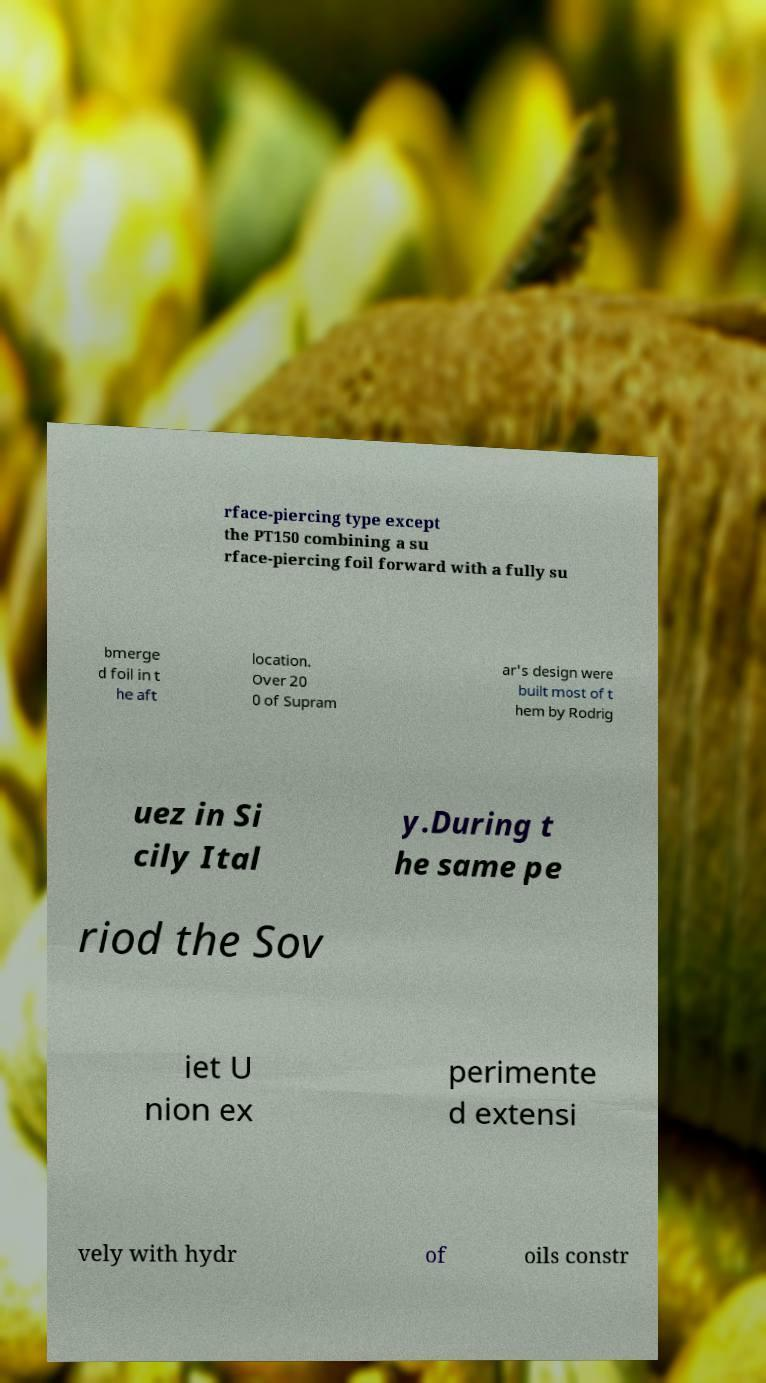Can you accurately transcribe the text from the provided image for me? rface-piercing type except the PT150 combining a su rface-piercing foil forward with a fully su bmerge d foil in t he aft location. Over 20 0 of Supram ar's design were built most of t hem by Rodrig uez in Si cily Ital y.During t he same pe riod the Sov iet U nion ex perimente d extensi vely with hydr of oils constr 